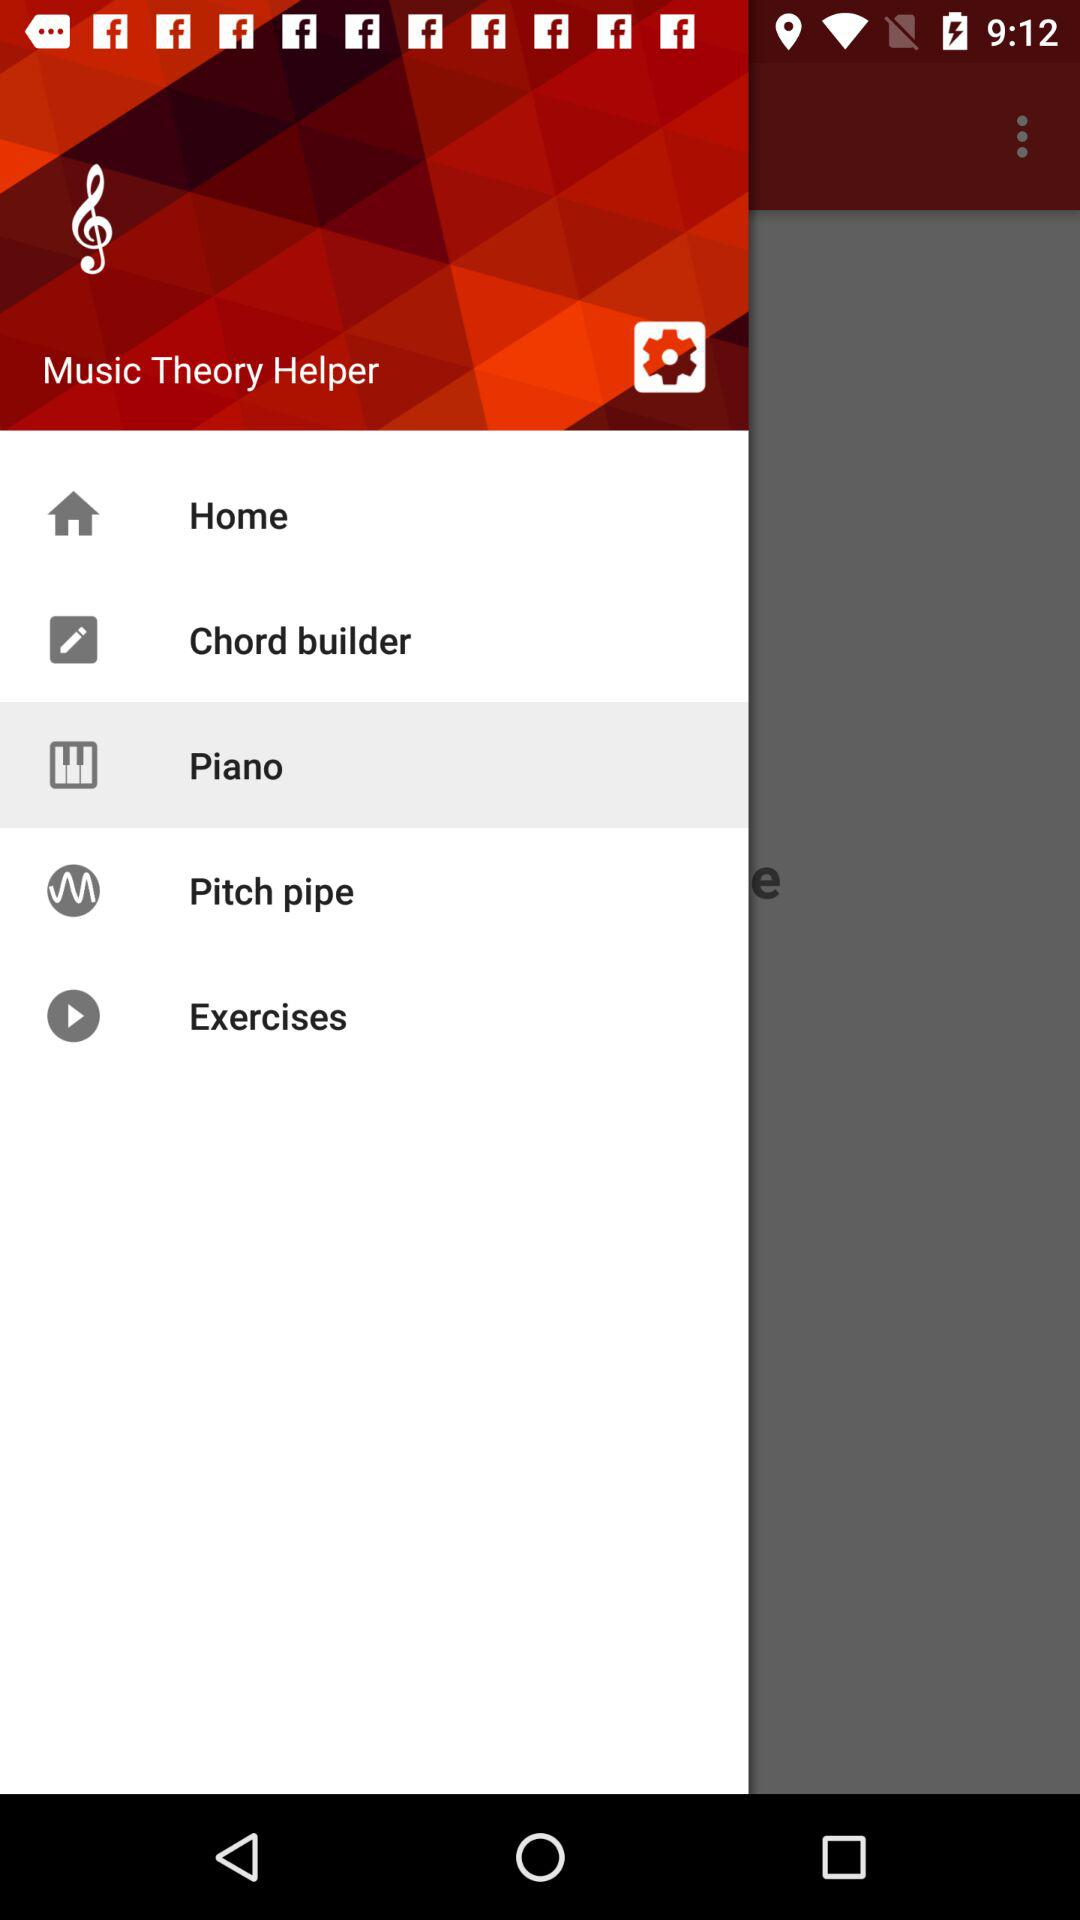What is the selected library? The selected library is "Piano". 